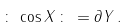Convert formula to latex. <formula><loc_0><loc_0><loc_500><loc_500>\colon \, \cos X \, \colon \, = \partial Y \, .</formula> 